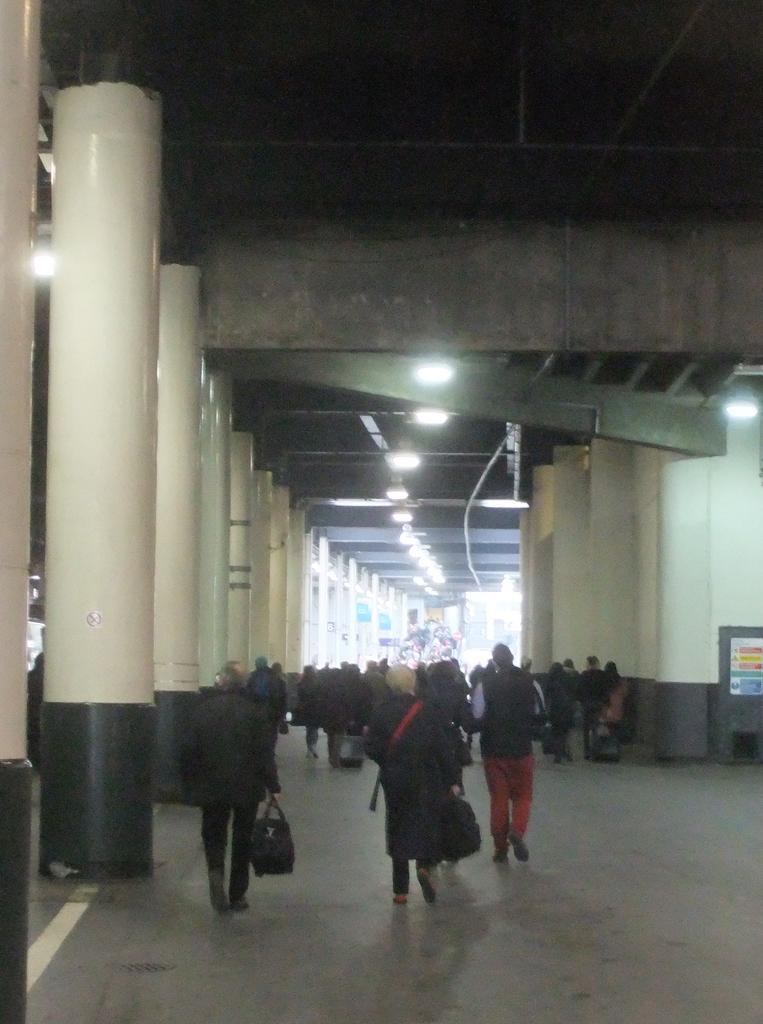Can you describe this image briefly? In this picture we can see the pillars, lights, boards, objects and the people. We can see few people are holding bags and walking. 